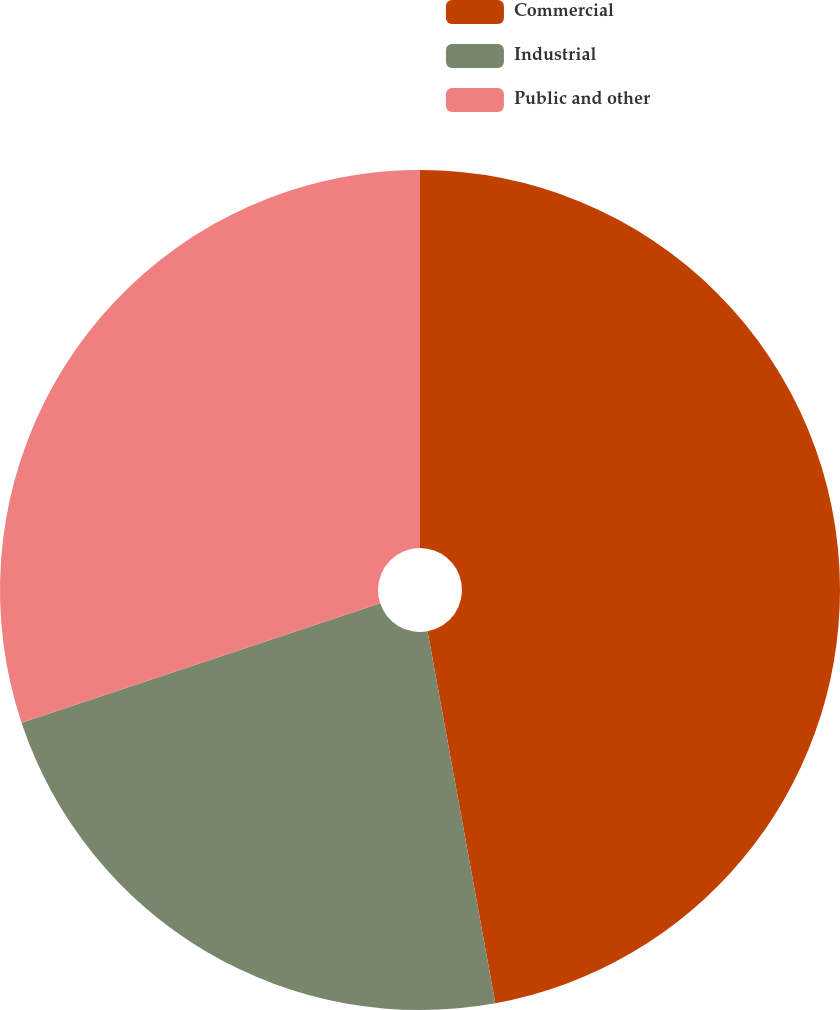Convert chart to OTSL. <chart><loc_0><loc_0><loc_500><loc_500><pie_chart><fcel>Commercial<fcel>Industrial<fcel>Public and other<nl><fcel>47.13%<fcel>22.75%<fcel>30.12%<nl></chart> 